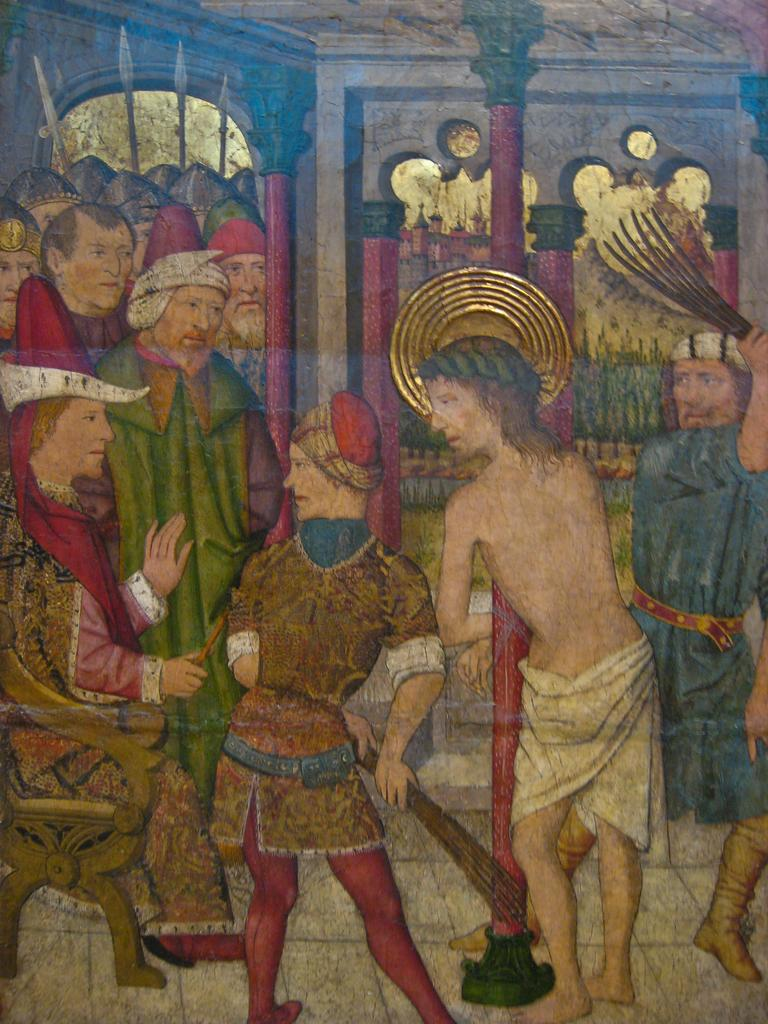What is the main subject of the image? There is an art piece in the image. What does the art piece depict? The art piece depicts a few people. Are there any architectural elements in the art piece? Yes, there are pillars and an arch in the art piece. What type of plastic material can be seen in the art piece? There is no plastic material present in the art piece; it is a two-dimensional representation. How many bananas are being held by the people in the art piece? There are no bananas depicted in the art piece; the people are not holding any fruits. 